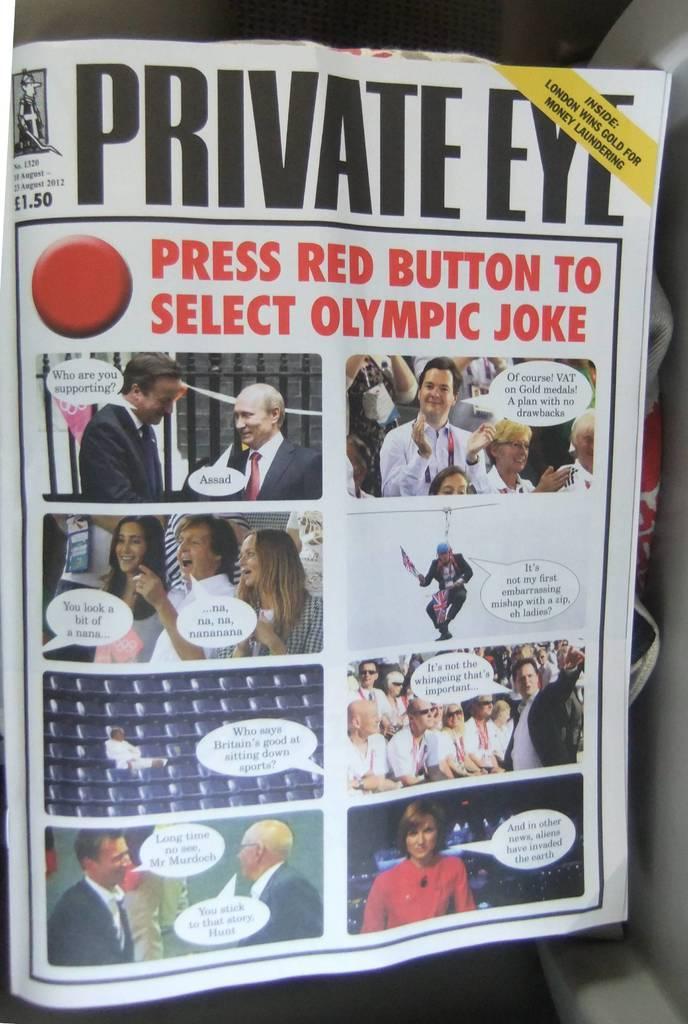Describe this image in one or two sentences. In the image we can see there is a newspaper and there is a collage of pictures. There are people standing and others are sitting on the chair. There is a message pop up on the paper and its written ¨Private Eye¨. 